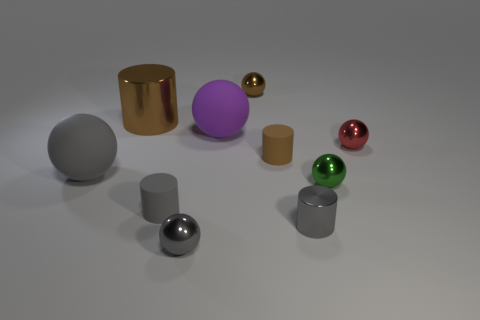Subtract all red balls. How many balls are left? 5 Subtract all tiny green balls. How many balls are left? 5 Subtract 2 balls. How many balls are left? 4 Subtract all brown balls. Subtract all blue cylinders. How many balls are left? 5 Subtract all spheres. How many objects are left? 4 Subtract 2 gray spheres. How many objects are left? 8 Subtract all gray objects. Subtract all tiny brown shiny objects. How many objects are left? 5 Add 7 small cylinders. How many small cylinders are left? 10 Add 2 big red matte objects. How many big red matte objects exist? 2 